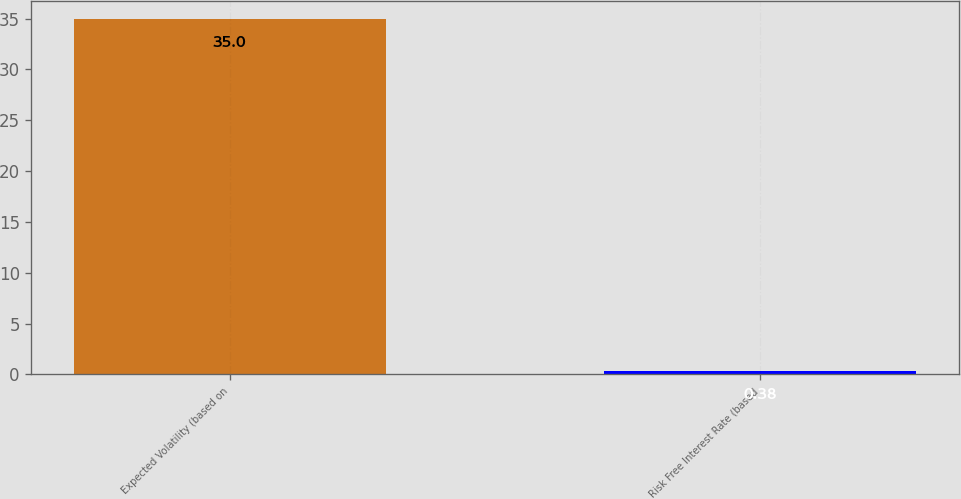<chart> <loc_0><loc_0><loc_500><loc_500><bar_chart><fcel>Expected Volatility (based on<fcel>Risk Free Interest Rate (based<nl><fcel>35<fcel>0.38<nl></chart> 